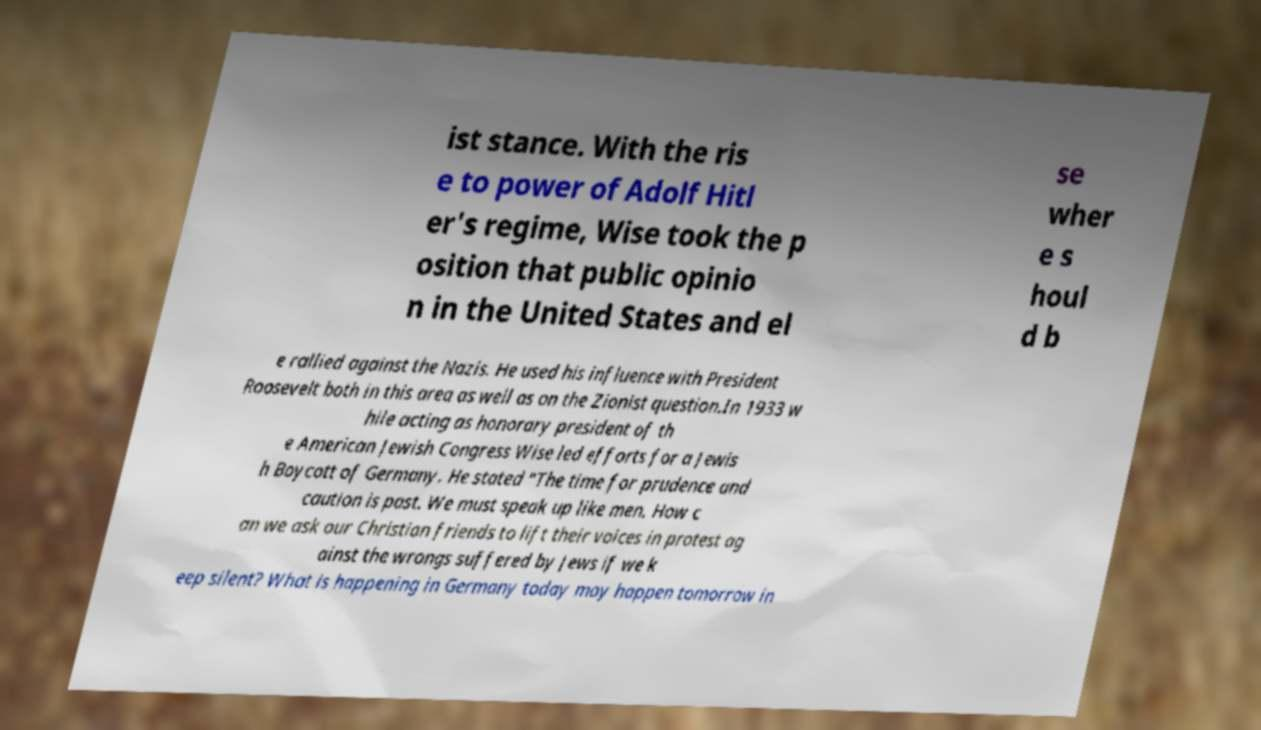Can you read and provide the text displayed in the image?This photo seems to have some interesting text. Can you extract and type it out for me? ist stance. With the ris e to power of Adolf Hitl er's regime, Wise took the p osition that public opinio n in the United States and el se wher e s houl d b e rallied against the Nazis. He used his influence with President Roosevelt both in this area as well as on the Zionist question.In 1933 w hile acting as honorary president of th e American Jewish Congress Wise led efforts for a Jewis h Boycott of Germany. He stated "The time for prudence and caution is past. We must speak up like men. How c an we ask our Christian friends to lift their voices in protest ag ainst the wrongs suffered by Jews if we k eep silent? What is happening in Germany today may happen tomorrow in 